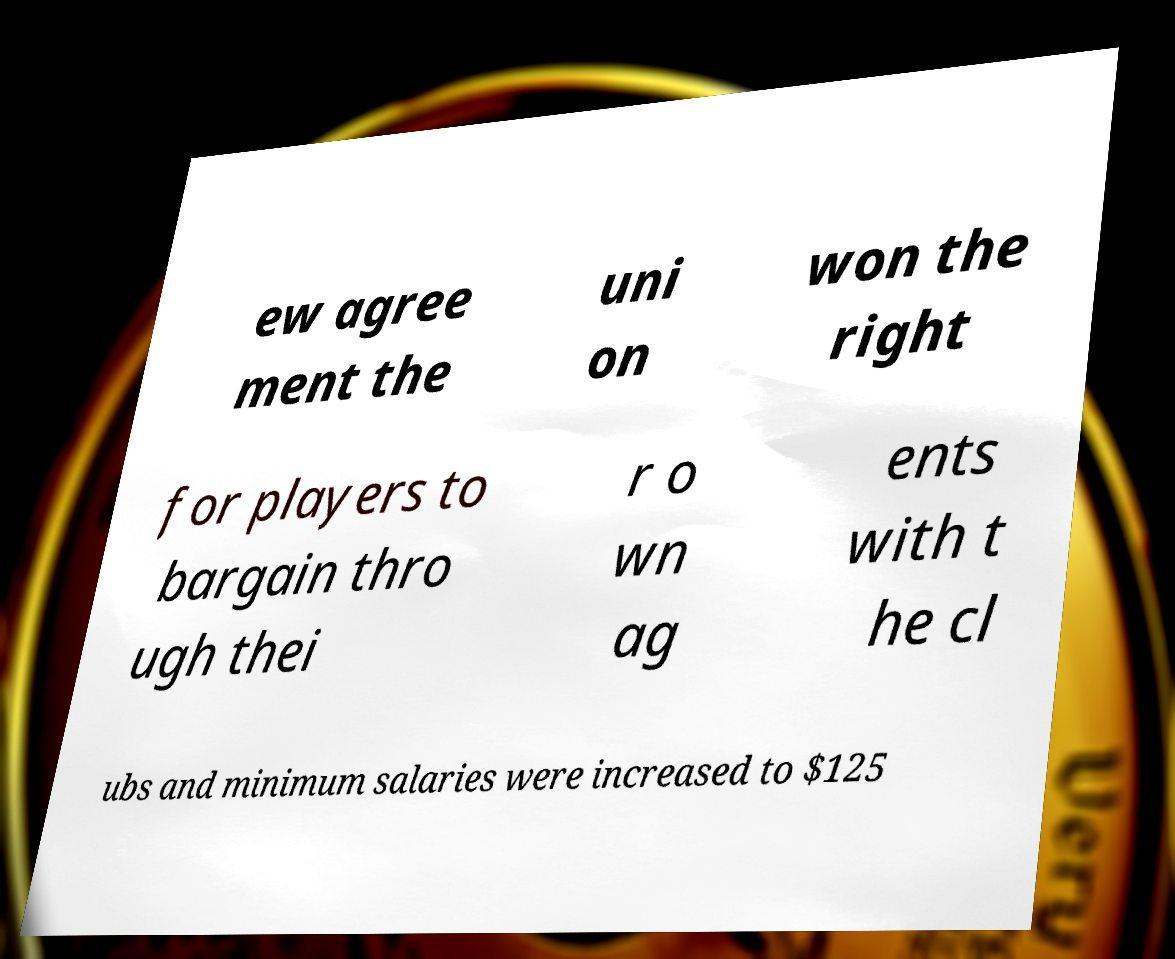For documentation purposes, I need the text within this image transcribed. Could you provide that? ew agree ment the uni on won the right for players to bargain thro ugh thei r o wn ag ents with t he cl ubs and minimum salaries were increased to $125 